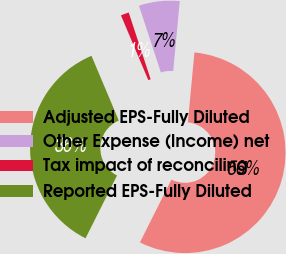<chart> <loc_0><loc_0><loc_500><loc_500><pie_chart><fcel>Adjusted EPS-Fully Diluted<fcel>Other Expense (Income) net<fcel>Tax impact of reconciling<fcel>Reported EPS-Fully Diluted<nl><fcel>55.9%<fcel>6.55%<fcel>1.31%<fcel>36.24%<nl></chart> 